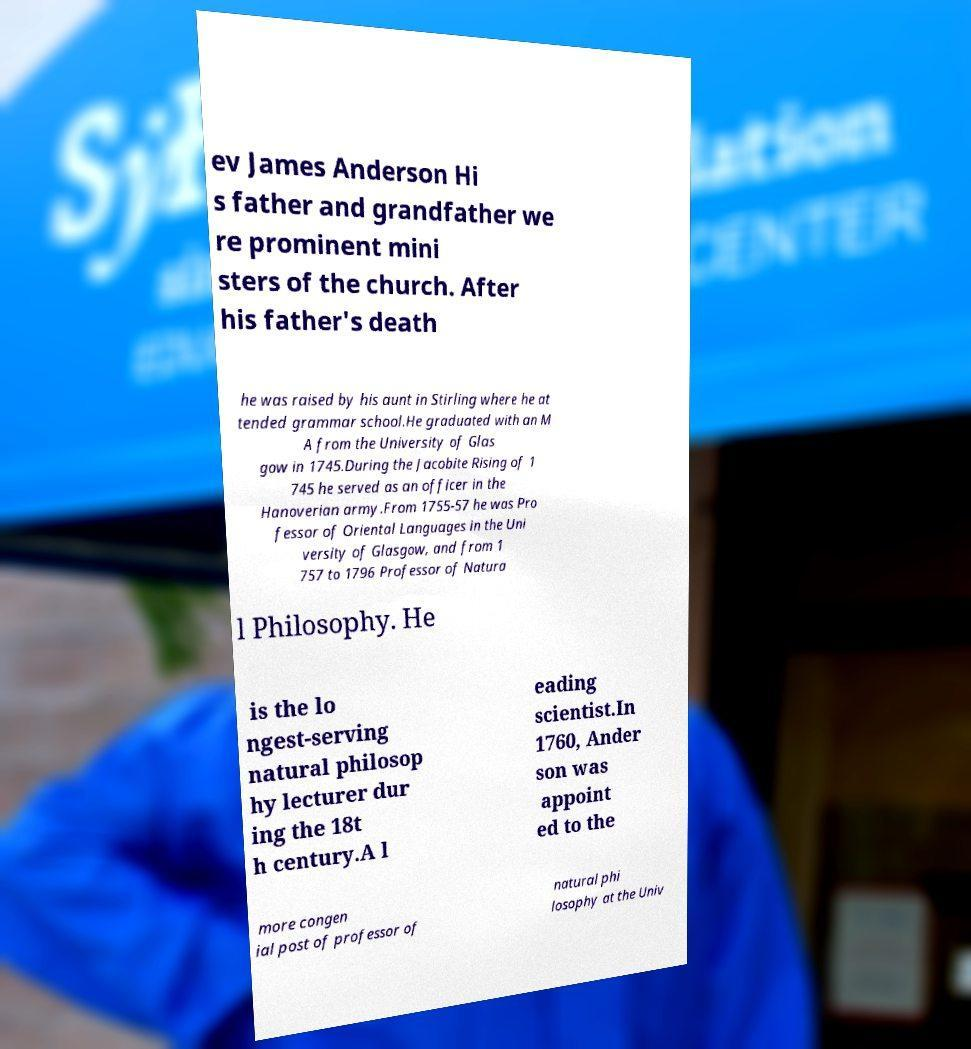For documentation purposes, I need the text within this image transcribed. Could you provide that? ev James Anderson Hi s father and grandfather we re prominent mini sters of the church. After his father's death he was raised by his aunt in Stirling where he at tended grammar school.He graduated with an M A from the University of Glas gow in 1745.During the Jacobite Rising of 1 745 he served as an officer in the Hanoverian army.From 1755-57 he was Pro fessor of Oriental Languages in the Uni versity of Glasgow, and from 1 757 to 1796 Professor of Natura l Philosophy. He is the lo ngest-serving natural philosop hy lecturer dur ing the 18t h century.A l eading scientist.In 1760, Ander son was appoint ed to the more congen ial post of professor of natural phi losophy at the Univ 